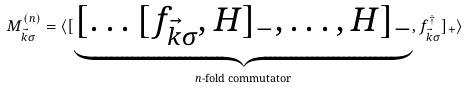Convert formula to latex. <formula><loc_0><loc_0><loc_500><loc_500>M _ { \vec { k } \sigma } ^ { ( n ) } = \langle [ \underbrace { [ \dots [ f _ { \vec { k } \sigma } , H ] _ { - } , \dots , H ] _ { - } } _ { \text {$n$-fold    commutator} } , f _ { \vec { k } \sigma } ^ { \dagger } ] _ { + } \rangle</formula> 